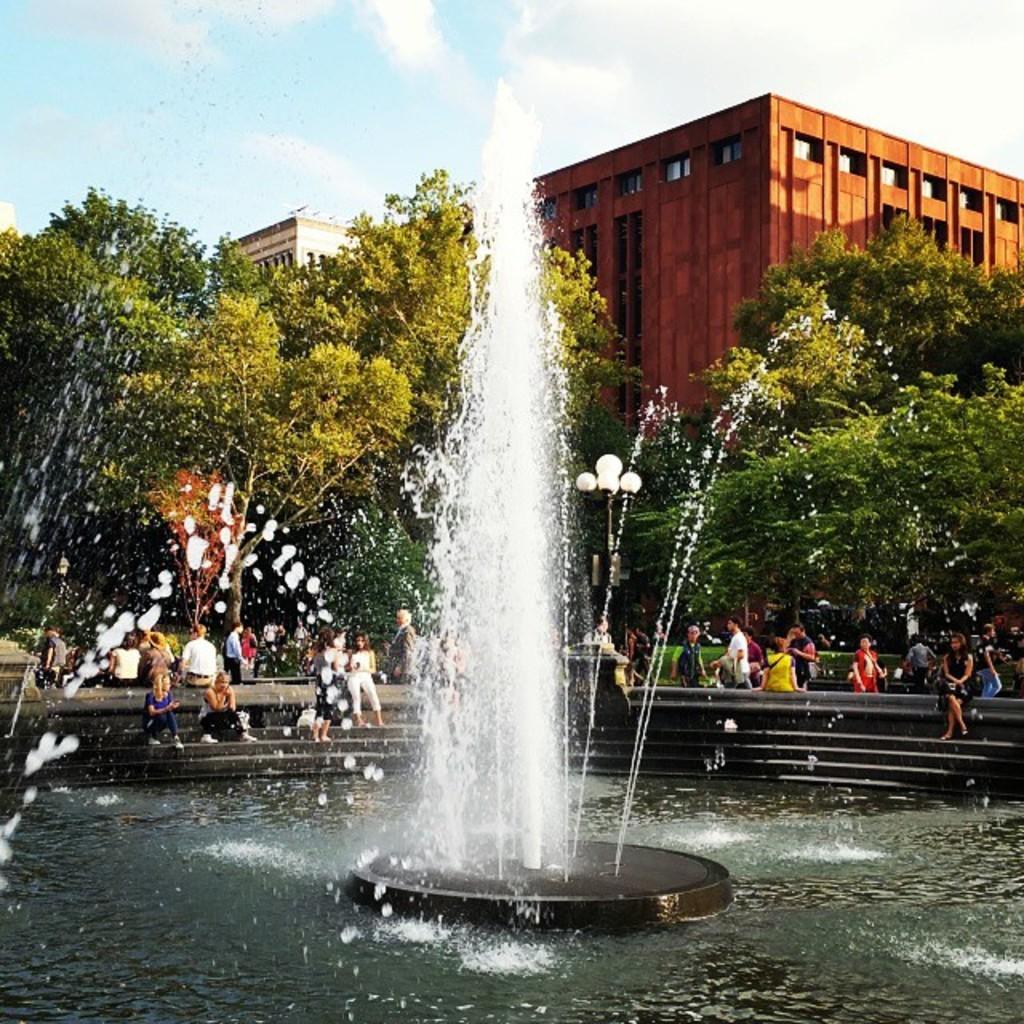How would you summarize this image in a sentence or two? In this picture we can see a fountain, water, trees, buildings and a group of people where some are sitting on steps and some are standing and in the background we can see the sky with clouds. 